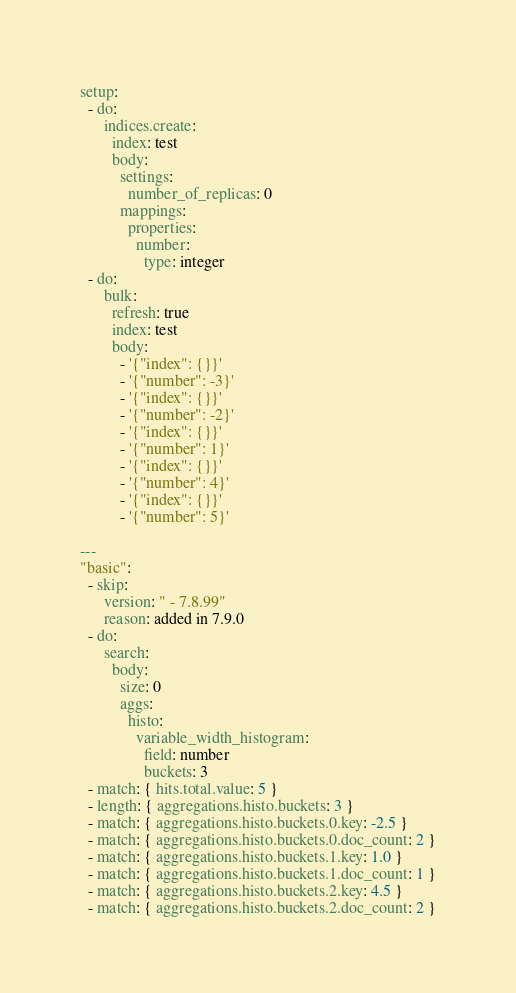<code> <loc_0><loc_0><loc_500><loc_500><_YAML_>setup:
  - do:
      indices.create:
        index: test
        body:
          settings:
            number_of_replicas: 0
          mappings:
            properties:
              number:
                type: integer
  - do:
      bulk:
        refresh: true
        index: test
        body:
          - '{"index": {}}'
          - '{"number": -3}'
          - '{"index": {}}'
          - '{"number": -2}'
          - '{"index": {}}'
          - '{"number": 1}'
          - '{"index": {}}'
          - '{"number": 4}'
          - '{"index": {}}'
          - '{"number": 5}'

---
"basic":
  - skip:
      version: " - 7.8.99"
      reason: added in 7.9.0
  - do:
      search:
        body:
          size: 0
          aggs:
            histo:
              variable_width_histogram:
                field: number
                buckets: 3
  - match: { hits.total.value: 5 }
  - length: { aggregations.histo.buckets: 3 }
  - match: { aggregations.histo.buckets.0.key: -2.5 }
  - match: { aggregations.histo.buckets.0.doc_count: 2 }
  - match: { aggregations.histo.buckets.1.key: 1.0 }
  - match: { aggregations.histo.buckets.1.doc_count: 1 }
  - match: { aggregations.histo.buckets.2.key: 4.5 }
  - match: { aggregations.histo.buckets.2.doc_count: 2 }

</code> 